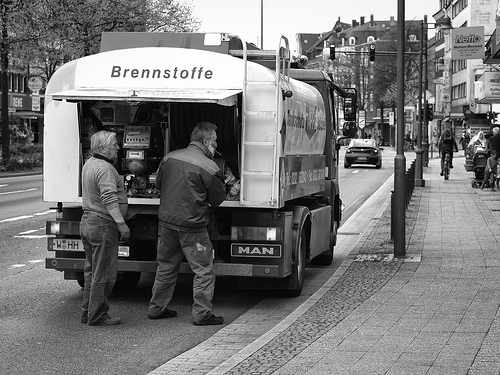What can we infer about the location depicted in the image? The image seems to be taken on a city street, as evidenced by the buildings in the background and the urban setting. The language 'Brennstoffe' on the truck is German, which may suggest that the location is somewhere in a German-speaking country. The presence of cyclists and the style of the street signs also hint at a European city atmosphere. 